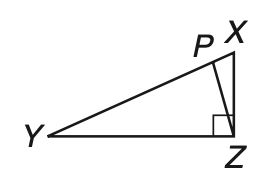Answer the mathemtical geometry problem and directly provide the correct option letter.
Question: Given right triangle X Y Z with hypotenuse X Y, Y P is equal to Y Z. If m \angle P Y Z = 26, find m \angle X Z P.
Choices: A: 13 B: 26 C: 32 D: 64 A 